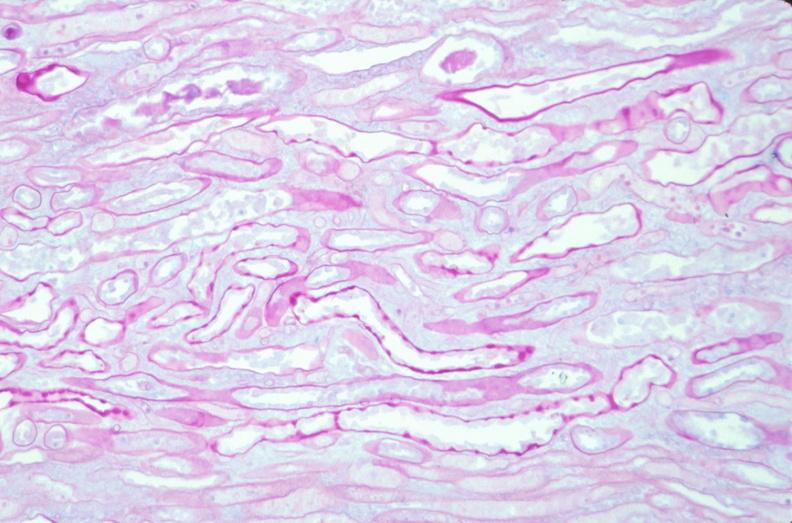where is this?
Answer the question using a single word or phrase. Urinary 